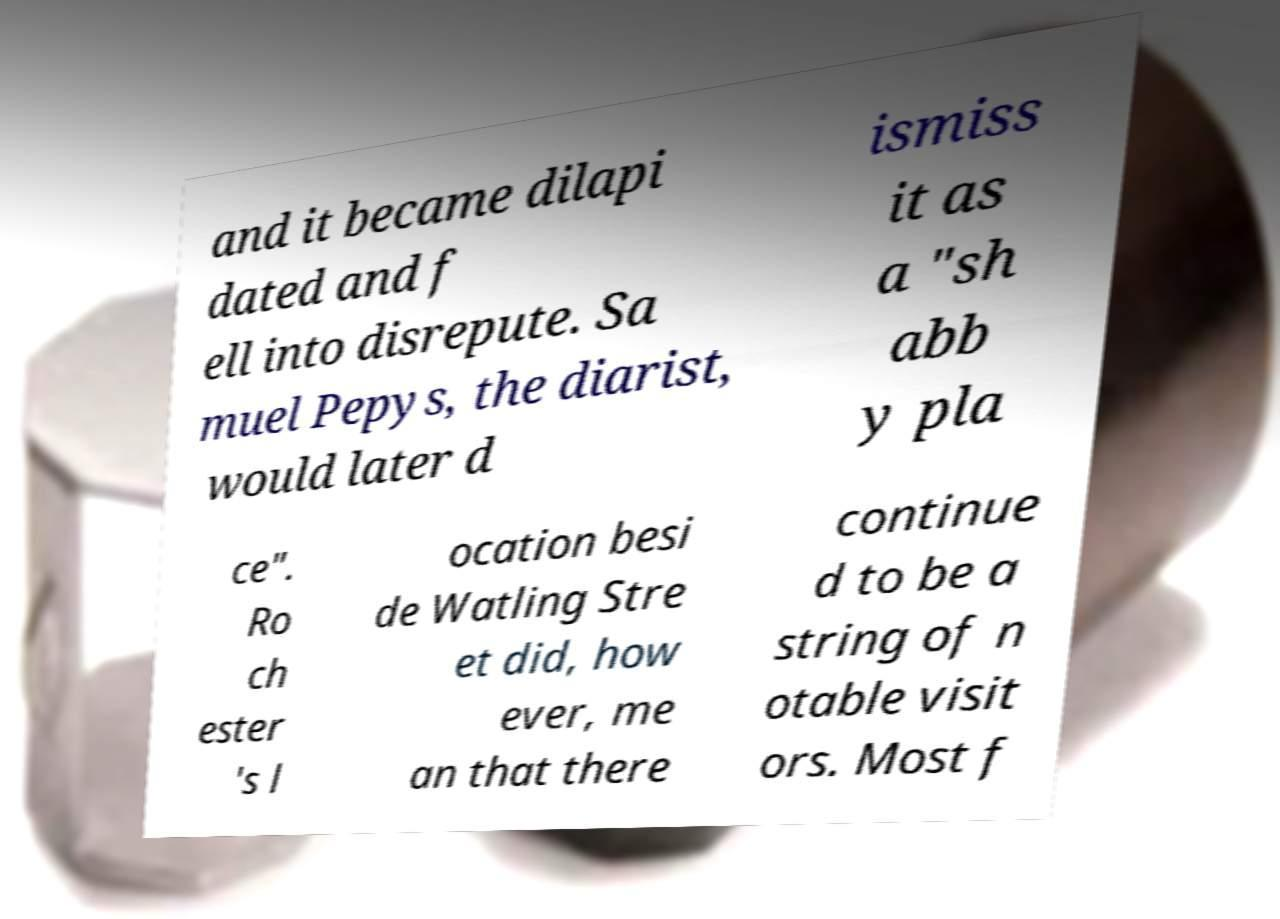Could you extract and type out the text from this image? and it became dilapi dated and f ell into disrepute. Sa muel Pepys, the diarist, would later d ismiss it as a "sh abb y pla ce". Ro ch ester 's l ocation besi de Watling Stre et did, how ever, me an that there continue d to be a string of n otable visit ors. Most f 